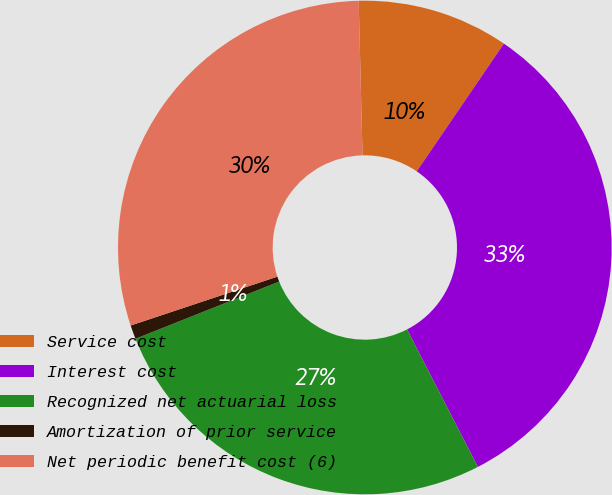<chart> <loc_0><loc_0><loc_500><loc_500><pie_chart><fcel>Service cost<fcel>Interest cost<fcel>Recognized net actuarial loss<fcel>Amortization of prior service<fcel>Net periodic benefit cost (6)<nl><fcel>9.92%<fcel>32.9%<fcel>26.54%<fcel>0.91%<fcel>29.72%<nl></chart> 